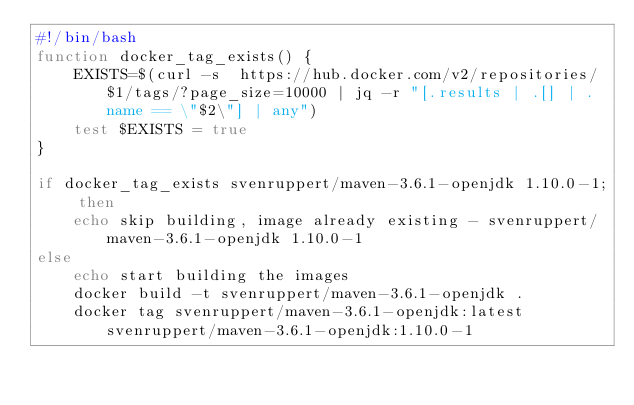<code> <loc_0><loc_0><loc_500><loc_500><_Bash_>#!/bin/bash
function docker_tag_exists() {
    EXISTS=$(curl -s  https://hub.docker.com/v2/repositories/$1/tags/?page_size=10000 | jq -r "[.results | .[] | .name == \"$2\"] | any")
    test $EXISTS = true
}

if docker_tag_exists svenruppert/maven-3.6.1-openjdk 1.10.0-1; then
    echo skip building, image already existing - svenruppert/maven-3.6.1-openjdk 1.10.0-1
else
    echo start building the images
    docker build -t svenruppert/maven-3.6.1-openjdk .
    docker tag svenruppert/maven-3.6.1-openjdk:latest svenruppert/maven-3.6.1-openjdk:1.10.0-1</code> 